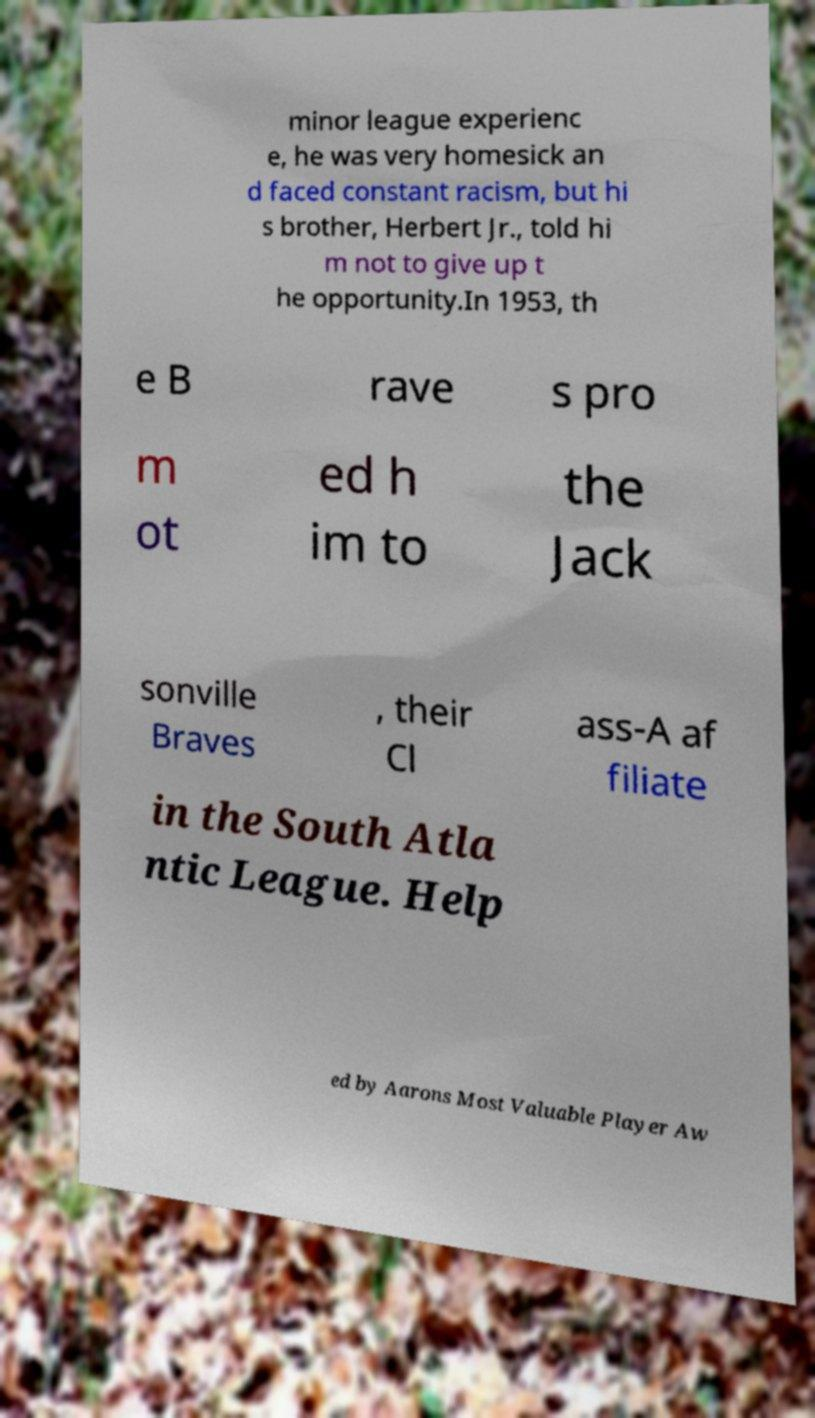Could you assist in decoding the text presented in this image and type it out clearly? minor league experienc e, he was very homesick an d faced constant racism, but hi s brother, Herbert Jr., told hi m not to give up t he opportunity.In 1953, th e B rave s pro m ot ed h im to the Jack sonville Braves , their Cl ass-A af filiate in the South Atla ntic League. Help ed by Aarons Most Valuable Player Aw 